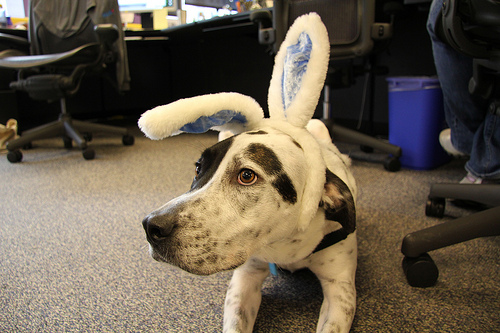<image>
Is the bunny ears on the dog? Yes. Looking at the image, I can see the bunny ears is positioned on top of the dog, with the dog providing support. 